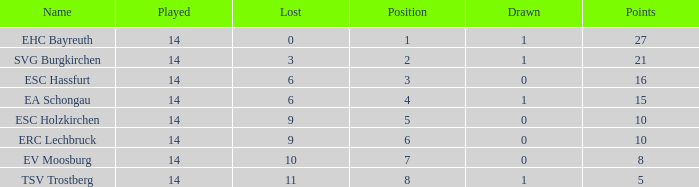Parse the table in full. {'header': ['Name', 'Played', 'Lost', 'Position', 'Drawn', 'Points'], 'rows': [['EHC Bayreuth', '14', '0', '1', '1', '27'], ['SVG Burgkirchen', '14', '3', '2', '1', '21'], ['ESC Hassfurt', '14', '6', '3', '0', '16'], ['EA Schongau', '14', '6', '4', '1', '15'], ['ESC Holzkirchen', '14', '9', '5', '0', '10'], ['ERC Lechbruck', '14', '9', '6', '0', '10'], ['EV Moosburg', '14', '10', '7', '0', '8'], ['TSV Trostberg', '14', '11', '8', '1', '5']]} What's the most points for Ea Schongau with more than 1 drawn? None. 